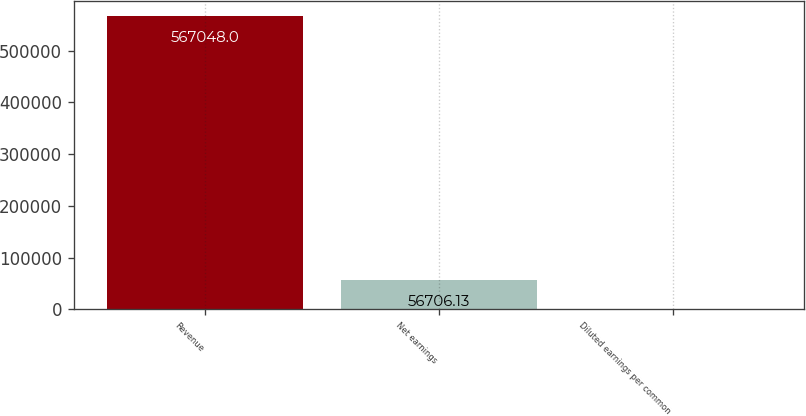<chart> <loc_0><loc_0><loc_500><loc_500><bar_chart><fcel>Revenue<fcel>Net earnings<fcel>Diluted earnings per common<nl><fcel>567048<fcel>56706.1<fcel>1.48<nl></chart> 